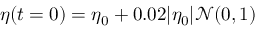<formula> <loc_0><loc_0><loc_500><loc_500>\eta ( t = 0 ) = \eta _ { 0 } + 0 . 0 2 | \eta _ { 0 } | \mathcal { N } ( 0 , 1 )</formula> 